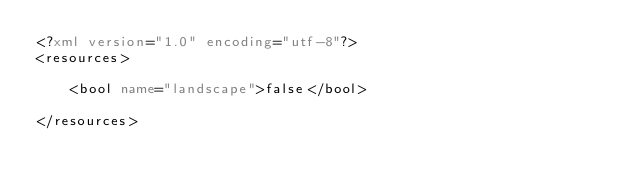Convert code to text. <code><loc_0><loc_0><loc_500><loc_500><_XML_><?xml version="1.0" encoding="utf-8"?>
<resources>

    <bool name="landscape">false</bool>

</resources></code> 